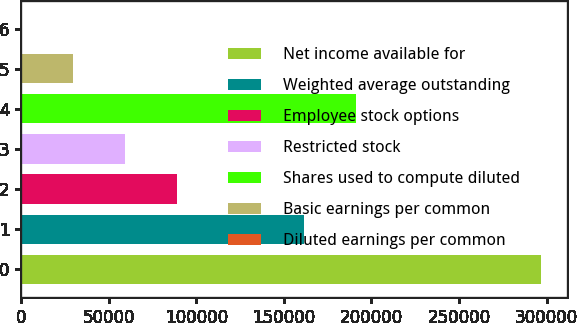Convert chart. <chart><loc_0><loc_0><loc_500><loc_500><bar_chart><fcel>Net income available for<fcel>Weighted average outstanding<fcel>Employee stock options<fcel>Restricted stock<fcel>Shares used to compute diluted<fcel>Basic earnings per common<fcel>Diluted earnings per common<nl><fcel>296730<fcel>161714<fcel>89020.2<fcel>59347.4<fcel>191387<fcel>29674.6<fcel>1.79<nl></chart> 